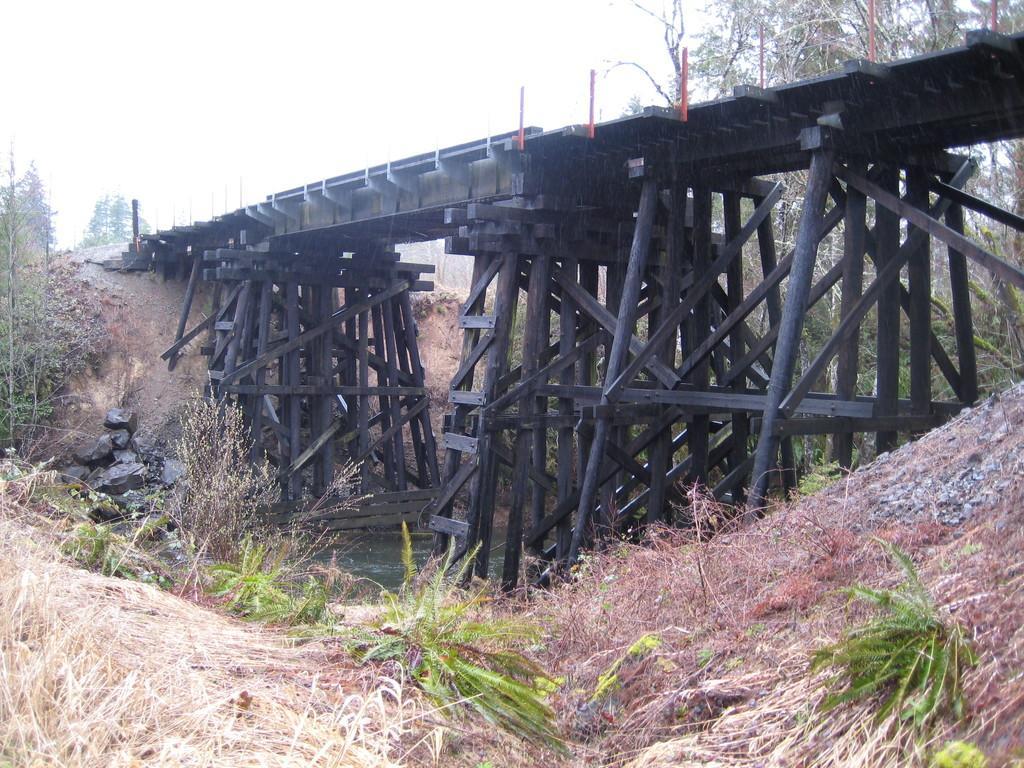Can you describe this image briefly? In this picture we can see grass and plants at the bottom, there is a bridge on the right side, we can see some rocks here, in the background there are trees, we can see the sky at the top of the picture. 